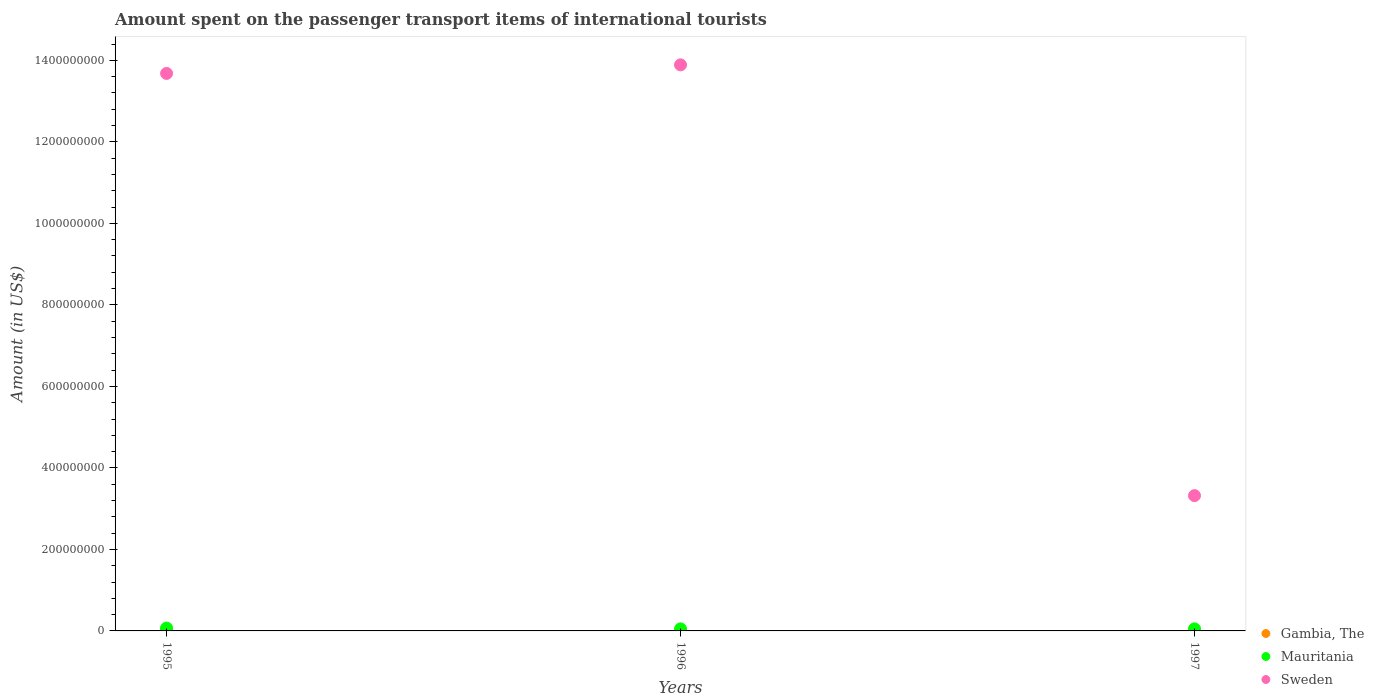How many different coloured dotlines are there?
Keep it short and to the point. 3. Is the number of dotlines equal to the number of legend labels?
Keep it short and to the point. Yes. What is the amount spent on the passenger transport items of international tourists in Mauritania in 1995?
Offer a terse response. 7.00e+06. Across all years, what is the minimum amount spent on the passenger transport items of international tourists in Gambia, The?
Provide a short and direct response. 5.00e+05. In which year was the amount spent on the passenger transport items of international tourists in Gambia, The maximum?
Your answer should be very brief. 1995. What is the total amount spent on the passenger transport items of international tourists in Gambia, The in the graph?
Make the answer very short. 3.50e+06. What is the difference between the amount spent on the passenger transport items of international tourists in Sweden in 1995 and that in 1996?
Ensure brevity in your answer.  -2.10e+07. What is the difference between the amount spent on the passenger transport items of international tourists in Sweden in 1995 and the amount spent on the passenger transport items of international tourists in Mauritania in 1996?
Provide a succinct answer. 1.36e+09. What is the average amount spent on the passenger transport items of international tourists in Gambia, The per year?
Your response must be concise. 1.17e+06. In the year 1997, what is the difference between the amount spent on the passenger transport items of international tourists in Gambia, The and amount spent on the passenger transport items of international tourists in Sweden?
Provide a short and direct response. -3.31e+08. In how many years, is the amount spent on the passenger transport items of international tourists in Sweden greater than 360000000 US$?
Ensure brevity in your answer.  2. What is the ratio of the amount spent on the passenger transport items of international tourists in Sweden in 1996 to that in 1997?
Offer a very short reply. 4.18. Is the difference between the amount spent on the passenger transport items of international tourists in Gambia, The in 1996 and 1997 greater than the difference between the amount spent on the passenger transport items of international tourists in Sweden in 1996 and 1997?
Ensure brevity in your answer.  No. What is the difference between the highest and the second highest amount spent on the passenger transport items of international tourists in Gambia, The?
Your answer should be compact. 1.00e+06. What is the difference between the highest and the lowest amount spent on the passenger transport items of international tourists in Gambia, The?
Keep it short and to the point. 1.50e+06. In how many years, is the amount spent on the passenger transport items of international tourists in Sweden greater than the average amount spent on the passenger transport items of international tourists in Sweden taken over all years?
Provide a succinct answer. 2. Is the sum of the amount spent on the passenger transport items of international tourists in Sweden in 1995 and 1997 greater than the maximum amount spent on the passenger transport items of international tourists in Mauritania across all years?
Provide a succinct answer. Yes. Is it the case that in every year, the sum of the amount spent on the passenger transport items of international tourists in Gambia, The and amount spent on the passenger transport items of international tourists in Sweden  is greater than the amount spent on the passenger transport items of international tourists in Mauritania?
Give a very brief answer. Yes. Is the amount spent on the passenger transport items of international tourists in Gambia, The strictly greater than the amount spent on the passenger transport items of international tourists in Mauritania over the years?
Give a very brief answer. No. Is the amount spent on the passenger transport items of international tourists in Mauritania strictly less than the amount spent on the passenger transport items of international tourists in Gambia, The over the years?
Ensure brevity in your answer.  No. How many years are there in the graph?
Your answer should be very brief. 3. What is the difference between two consecutive major ticks on the Y-axis?
Ensure brevity in your answer.  2.00e+08. Does the graph contain any zero values?
Offer a terse response. No. How many legend labels are there?
Offer a terse response. 3. What is the title of the graph?
Offer a very short reply. Amount spent on the passenger transport items of international tourists. Does "Malaysia" appear as one of the legend labels in the graph?
Ensure brevity in your answer.  No. What is the label or title of the X-axis?
Give a very brief answer. Years. What is the label or title of the Y-axis?
Your answer should be very brief. Amount (in US$). What is the Amount (in US$) in Gambia, The in 1995?
Your response must be concise. 2.00e+06. What is the Amount (in US$) of Mauritania in 1995?
Offer a very short reply. 7.00e+06. What is the Amount (in US$) of Sweden in 1995?
Make the answer very short. 1.37e+09. What is the Amount (in US$) of Mauritania in 1996?
Keep it short and to the point. 5.00e+06. What is the Amount (in US$) of Sweden in 1996?
Your answer should be compact. 1.39e+09. What is the Amount (in US$) in Sweden in 1997?
Provide a short and direct response. 3.32e+08. Across all years, what is the maximum Amount (in US$) in Gambia, The?
Give a very brief answer. 2.00e+06. Across all years, what is the maximum Amount (in US$) in Mauritania?
Offer a terse response. 7.00e+06. Across all years, what is the maximum Amount (in US$) in Sweden?
Make the answer very short. 1.39e+09. Across all years, what is the minimum Amount (in US$) in Gambia, The?
Your response must be concise. 5.00e+05. Across all years, what is the minimum Amount (in US$) in Sweden?
Your answer should be compact. 3.32e+08. What is the total Amount (in US$) in Gambia, The in the graph?
Keep it short and to the point. 3.50e+06. What is the total Amount (in US$) in Mauritania in the graph?
Ensure brevity in your answer.  1.70e+07. What is the total Amount (in US$) of Sweden in the graph?
Give a very brief answer. 3.09e+09. What is the difference between the Amount (in US$) of Gambia, The in 1995 and that in 1996?
Provide a short and direct response. 1.50e+06. What is the difference between the Amount (in US$) in Mauritania in 1995 and that in 1996?
Your answer should be very brief. 2.00e+06. What is the difference between the Amount (in US$) of Sweden in 1995 and that in 1996?
Provide a short and direct response. -2.10e+07. What is the difference between the Amount (in US$) of Mauritania in 1995 and that in 1997?
Your answer should be compact. 2.00e+06. What is the difference between the Amount (in US$) of Sweden in 1995 and that in 1997?
Make the answer very short. 1.04e+09. What is the difference between the Amount (in US$) of Gambia, The in 1996 and that in 1997?
Offer a very short reply. -5.00e+05. What is the difference between the Amount (in US$) in Sweden in 1996 and that in 1997?
Make the answer very short. 1.06e+09. What is the difference between the Amount (in US$) in Gambia, The in 1995 and the Amount (in US$) in Sweden in 1996?
Offer a terse response. -1.39e+09. What is the difference between the Amount (in US$) in Mauritania in 1995 and the Amount (in US$) in Sweden in 1996?
Ensure brevity in your answer.  -1.38e+09. What is the difference between the Amount (in US$) of Gambia, The in 1995 and the Amount (in US$) of Sweden in 1997?
Provide a succinct answer. -3.30e+08. What is the difference between the Amount (in US$) of Mauritania in 1995 and the Amount (in US$) of Sweden in 1997?
Provide a succinct answer. -3.25e+08. What is the difference between the Amount (in US$) of Gambia, The in 1996 and the Amount (in US$) of Mauritania in 1997?
Provide a succinct answer. -4.50e+06. What is the difference between the Amount (in US$) of Gambia, The in 1996 and the Amount (in US$) of Sweden in 1997?
Offer a terse response. -3.32e+08. What is the difference between the Amount (in US$) in Mauritania in 1996 and the Amount (in US$) in Sweden in 1997?
Offer a terse response. -3.27e+08. What is the average Amount (in US$) of Gambia, The per year?
Provide a succinct answer. 1.17e+06. What is the average Amount (in US$) in Mauritania per year?
Offer a very short reply. 5.67e+06. What is the average Amount (in US$) of Sweden per year?
Provide a succinct answer. 1.03e+09. In the year 1995, what is the difference between the Amount (in US$) of Gambia, The and Amount (in US$) of Mauritania?
Offer a terse response. -5.00e+06. In the year 1995, what is the difference between the Amount (in US$) of Gambia, The and Amount (in US$) of Sweden?
Your answer should be compact. -1.37e+09. In the year 1995, what is the difference between the Amount (in US$) of Mauritania and Amount (in US$) of Sweden?
Make the answer very short. -1.36e+09. In the year 1996, what is the difference between the Amount (in US$) in Gambia, The and Amount (in US$) in Mauritania?
Your response must be concise. -4.50e+06. In the year 1996, what is the difference between the Amount (in US$) of Gambia, The and Amount (in US$) of Sweden?
Ensure brevity in your answer.  -1.39e+09. In the year 1996, what is the difference between the Amount (in US$) in Mauritania and Amount (in US$) in Sweden?
Make the answer very short. -1.38e+09. In the year 1997, what is the difference between the Amount (in US$) of Gambia, The and Amount (in US$) of Mauritania?
Offer a terse response. -4.00e+06. In the year 1997, what is the difference between the Amount (in US$) of Gambia, The and Amount (in US$) of Sweden?
Your answer should be very brief. -3.31e+08. In the year 1997, what is the difference between the Amount (in US$) in Mauritania and Amount (in US$) in Sweden?
Your response must be concise. -3.27e+08. What is the ratio of the Amount (in US$) of Sweden in 1995 to that in 1996?
Ensure brevity in your answer.  0.98. What is the ratio of the Amount (in US$) of Gambia, The in 1995 to that in 1997?
Your response must be concise. 2. What is the ratio of the Amount (in US$) in Sweden in 1995 to that in 1997?
Your answer should be very brief. 4.12. What is the ratio of the Amount (in US$) in Gambia, The in 1996 to that in 1997?
Provide a short and direct response. 0.5. What is the ratio of the Amount (in US$) of Sweden in 1996 to that in 1997?
Offer a very short reply. 4.18. What is the difference between the highest and the second highest Amount (in US$) of Sweden?
Give a very brief answer. 2.10e+07. What is the difference between the highest and the lowest Amount (in US$) of Gambia, The?
Your answer should be compact. 1.50e+06. What is the difference between the highest and the lowest Amount (in US$) in Sweden?
Your response must be concise. 1.06e+09. 